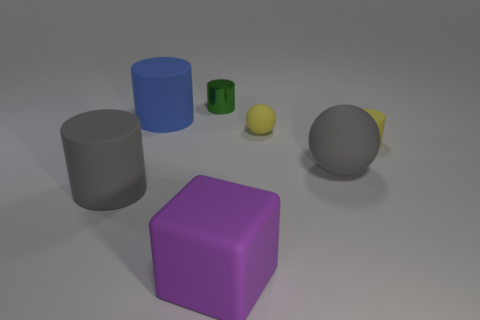Add 1 big blue matte things. How many objects exist? 8 Subtract 1 blocks. How many blocks are left? 0 Subtract all yellow matte cylinders. How many cylinders are left? 3 Subtract all cubes. How many objects are left? 6 Add 6 big blocks. How many big blocks are left? 7 Add 7 yellow matte spheres. How many yellow matte spheres exist? 8 Subtract all yellow balls. How many balls are left? 1 Subtract 0 cyan cylinders. How many objects are left? 7 Subtract all cyan cubes. Subtract all purple cylinders. How many cubes are left? 1 Subtract all cyan balls. How many gray blocks are left? 0 